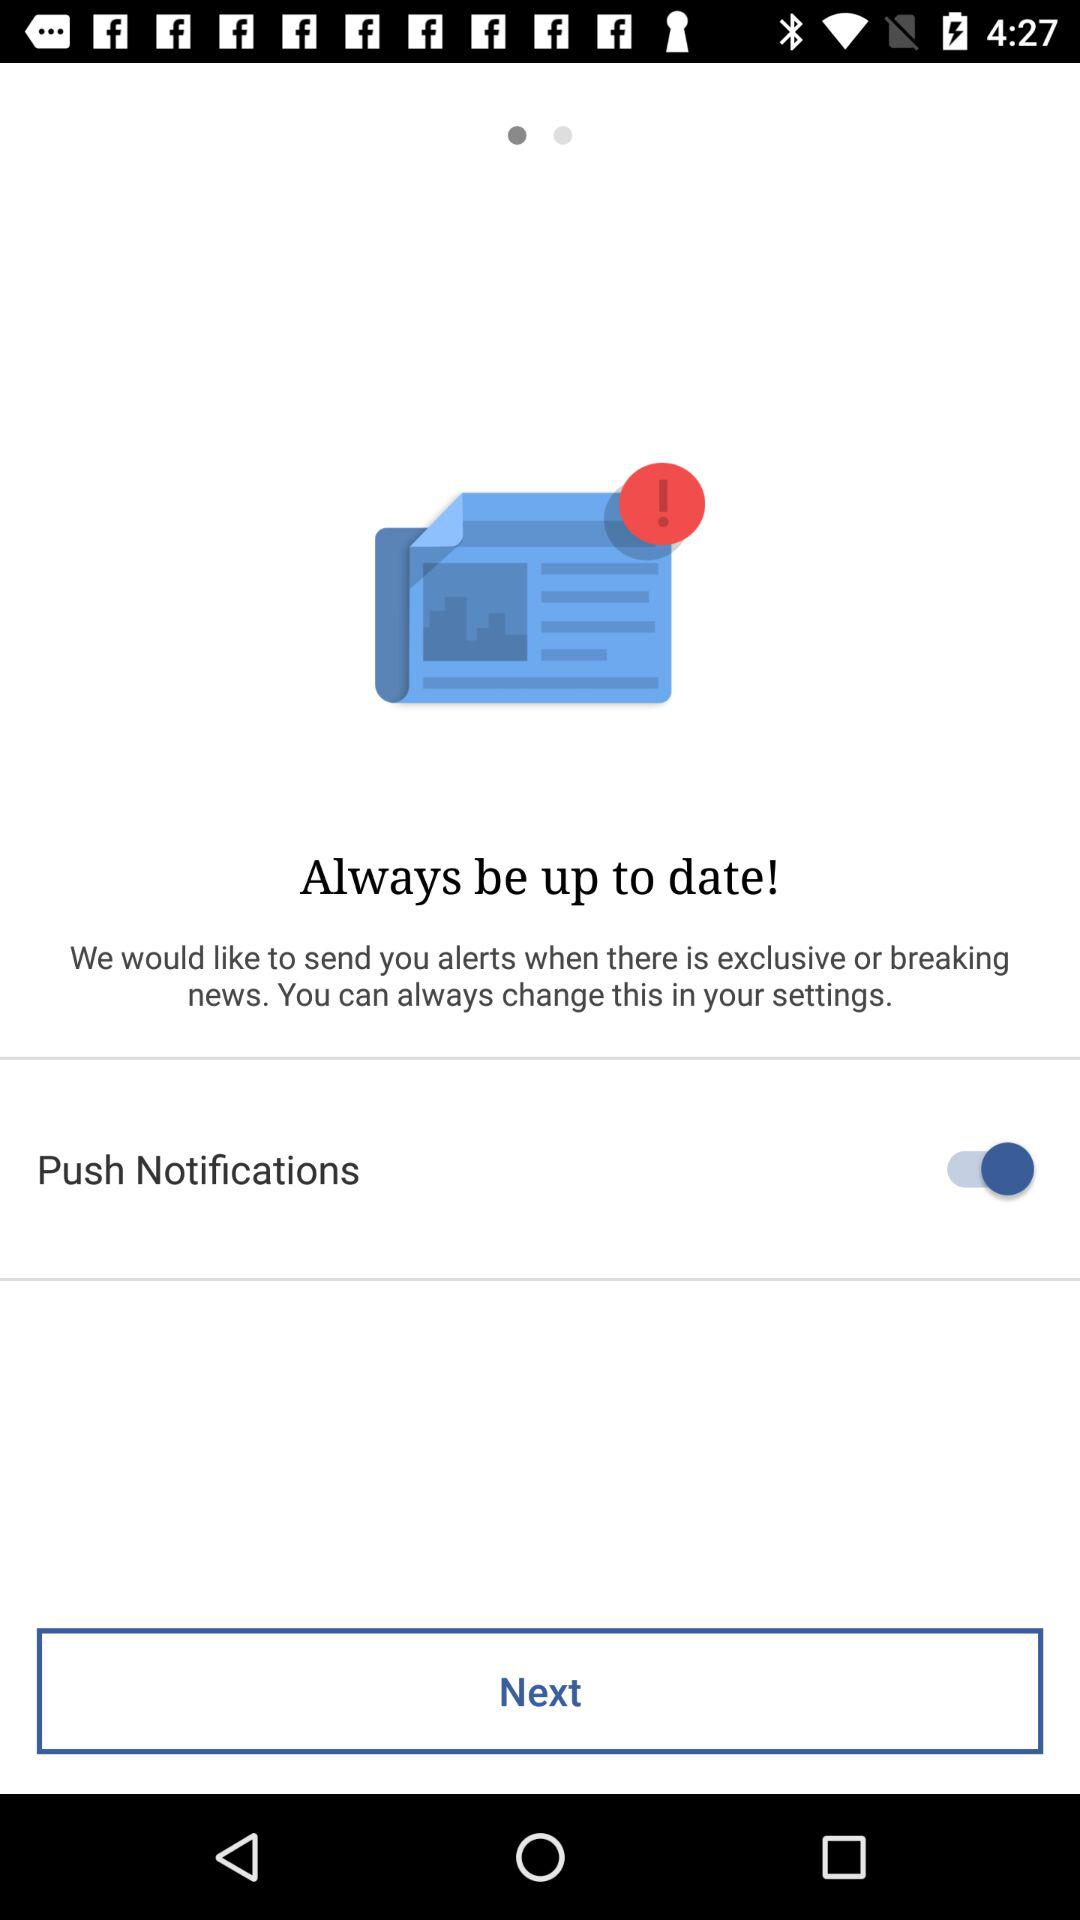Is "Push Notifications" enabled or disabled? "Push Notifications" is enabled. 